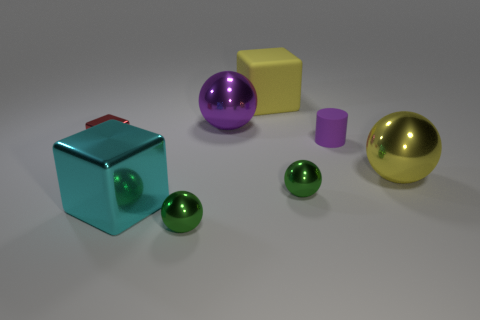Add 1 big metal blocks. How many objects exist? 9 Subtract all cylinders. How many objects are left? 7 Add 8 tiny green metal cylinders. How many tiny green metal cylinders exist? 8 Subtract 1 yellow cubes. How many objects are left? 7 Subtract all big blue shiny spheres. Subtract all large balls. How many objects are left? 6 Add 6 large yellow objects. How many large yellow objects are left? 8 